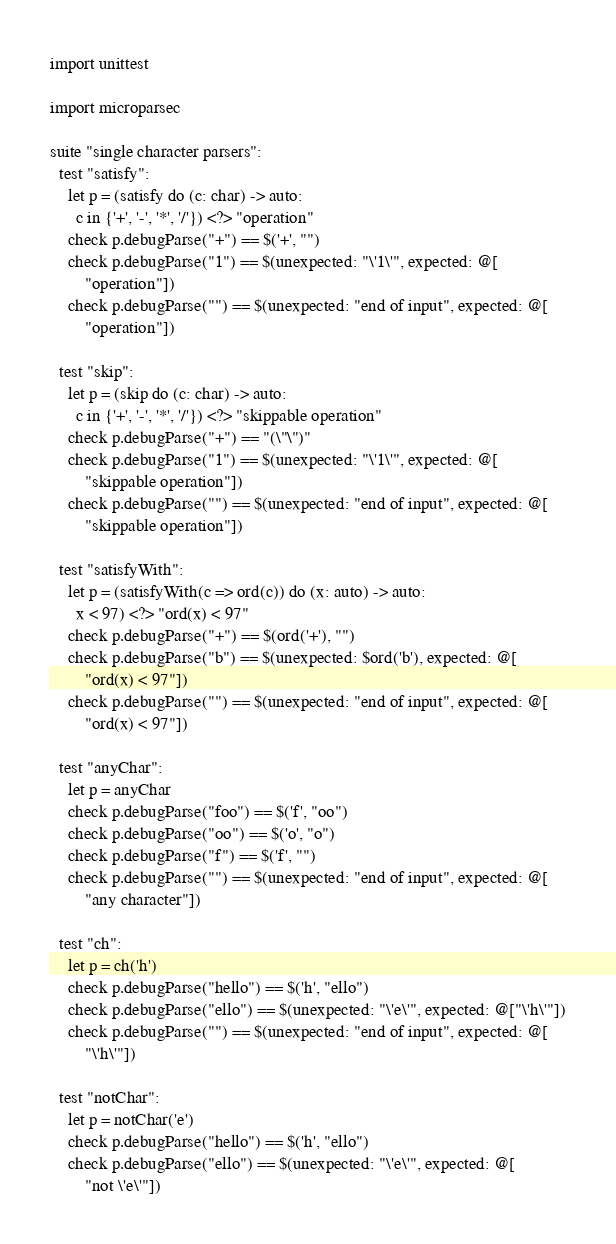<code> <loc_0><loc_0><loc_500><loc_500><_Nim_>import unittest

import microparsec

suite "single character parsers":
  test "satisfy":
    let p = (satisfy do (c: char) -> auto:
      c in {'+', '-', '*', '/'}) <?> "operation"
    check p.debugParse("+") == $('+', "")
    check p.debugParse("1") == $(unexpected: "\'1\'", expected: @[
        "operation"])
    check p.debugParse("") == $(unexpected: "end of input", expected: @[
        "operation"])

  test "skip":
    let p = (skip do (c: char) -> auto:
      c in {'+', '-', '*', '/'}) <?> "skippable operation"
    check p.debugParse("+") == "(\"\")"
    check p.debugParse("1") == $(unexpected: "\'1\'", expected: @[
        "skippable operation"])
    check p.debugParse("") == $(unexpected: "end of input", expected: @[
        "skippable operation"])

  test "satisfyWith":
    let p = (satisfyWith(c => ord(c)) do (x: auto) -> auto:
      x < 97) <?> "ord(x) < 97"
    check p.debugParse("+") == $(ord('+'), "")
    check p.debugParse("b") == $(unexpected: $ord('b'), expected: @[
        "ord(x) < 97"])
    check p.debugParse("") == $(unexpected: "end of input", expected: @[
        "ord(x) < 97"])

  test "anyChar":
    let p = anyChar
    check p.debugParse("foo") == $('f', "oo")
    check p.debugParse("oo") == $('o', "o")
    check p.debugParse("f") == $('f', "")
    check p.debugParse("") == $(unexpected: "end of input", expected: @[
        "any character"])

  test "ch":
    let p = ch('h')
    check p.debugParse("hello") == $('h', "ello")
    check p.debugParse("ello") == $(unexpected: "\'e\'", expected: @["\'h\'"])
    check p.debugParse("") == $(unexpected: "end of input", expected: @[
        "\'h\'"])

  test "notChar":
    let p = notChar('e')
    check p.debugParse("hello") == $('h', "ello")
    check p.debugParse("ello") == $(unexpected: "\'e\'", expected: @[
        "not \'e\'"])</code> 